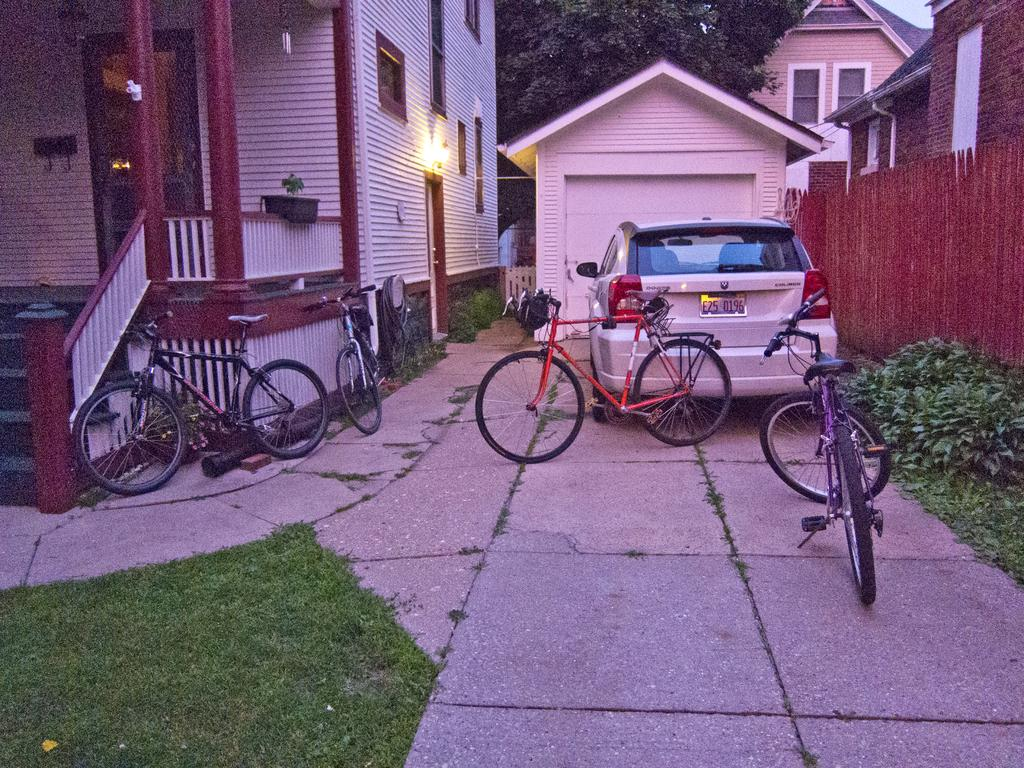What type of vehicles are in the image? There are bicycles and a car in the image. Where is the car located in relation to the house? The car is in front of a house in the image. What type of vegetation can be seen in the image? There are plants and a tree in the image. What is the ground covered with in the image? There is grass on the ground in the image. How many houses are visible in the image? There are houses in the image. Can you hear the horn of the donkey in the image? There is no donkey present in the image, and therefore no horn can be heard. 